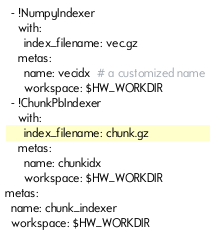Convert code to text. <code><loc_0><loc_0><loc_500><loc_500><_YAML_>  - !NumpyIndexer
    with:
      index_filename: vec.gz
    metas:
      name: vecidx  # a customized name
      workspace: $HW_WORKDIR
  - !ChunkPbIndexer
    with:
      index_filename: chunk.gz
    metas:
      name: chunkidx
      workspace: $HW_WORKDIR
metas:
  name: chunk_indexer
  workspace: $HW_WORKDIR</code> 